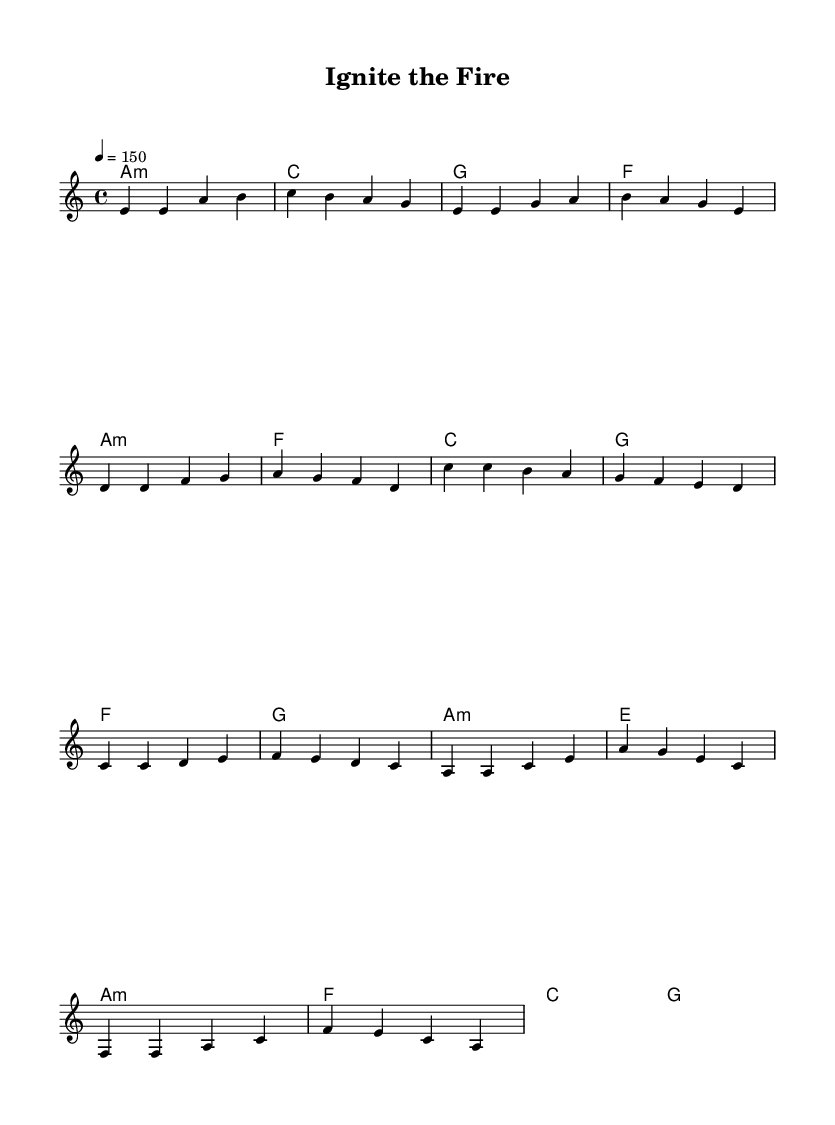What is the key signature of this music? The key signature is A minor, which has no sharps or flats.
Answer: A minor What is the time signature of this music? The time signature is found at the beginning of the piece, indicating how many beats are in each measure. Here, it is 4/4.
Answer: 4/4 What is the tempo marking of this piece? The tempo marking, shown at the beginning, indicates the speed of the piece; it is set at 150 beats per minute.
Answer: 150 How many measures are in the chorus section? Counting the measures in the chorus, there are four measures indicated.
Answer: 4 What type of chord is used during the intro? The chord used in the intro starts with the A minor chord as indicated in the harmonies.
Answer: A minor Which section is characterized by rising melodic lines and dynamic shifts? The pre-chorus typically features rising melodic lines and dynamic shifts, preparing for the explosive chorus.
Answer: Pre-Chorus What is the rhythmic feel associated with K-Pop tracks like this one? The rhythmic feel often includes a driving beat with syncopation, which enhances the energetic dance vibe typical of K-Pop music.
Answer: Driving beat 